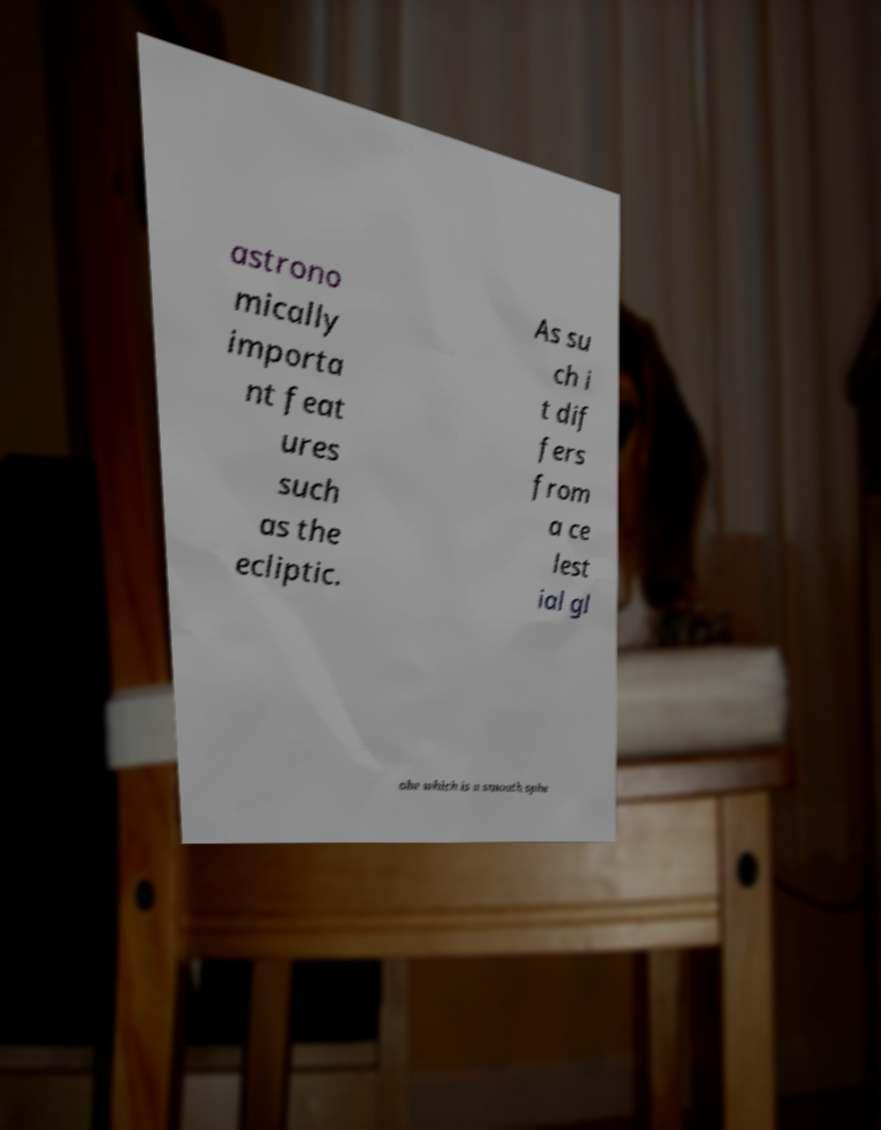Could you assist in decoding the text presented in this image and type it out clearly? astrono mically importa nt feat ures such as the ecliptic. As su ch i t dif fers from a ce lest ial gl obe which is a smooth sphe 